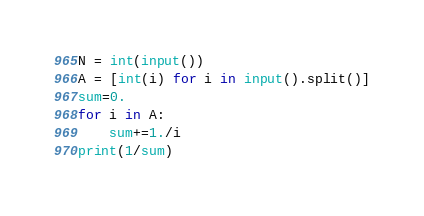Convert code to text. <code><loc_0><loc_0><loc_500><loc_500><_Python_>N = int(input())
A = [int(i) for i in input().split()]
sum=0.
for i in A:
    sum+=1./i
print(1/sum)</code> 